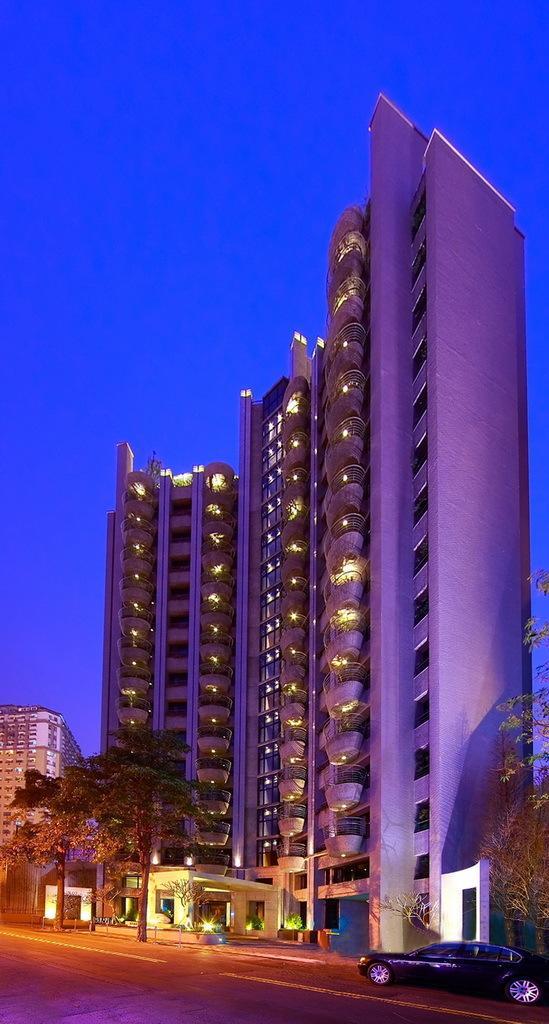Can you describe this image briefly? In this image I can see buildings, trees and vehicle on the road. In the background I can see the sky. 